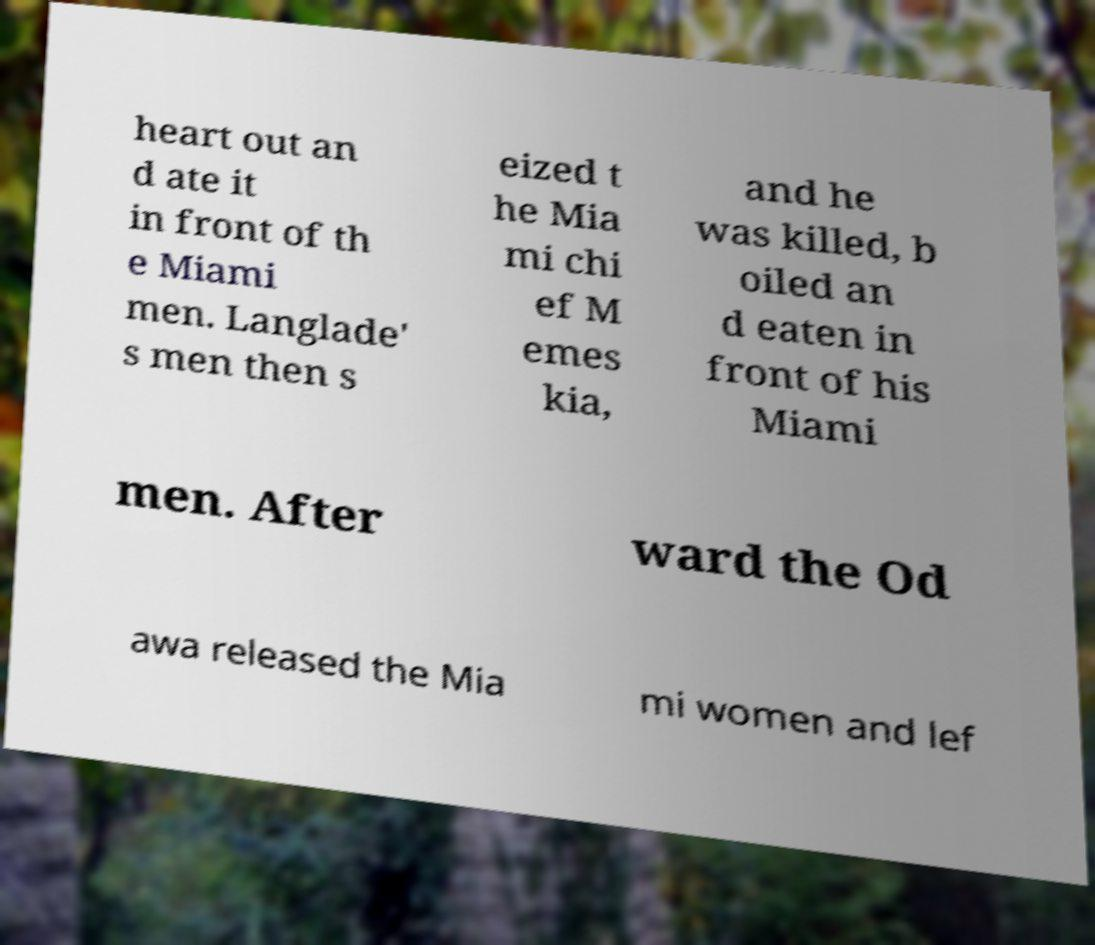Could you extract and type out the text from this image? heart out an d ate it in front of th e Miami men. Langlade' s men then s eized t he Mia mi chi ef M emes kia, and he was killed, b oiled an d eaten in front of his Miami men. After ward the Od awa released the Mia mi women and lef 